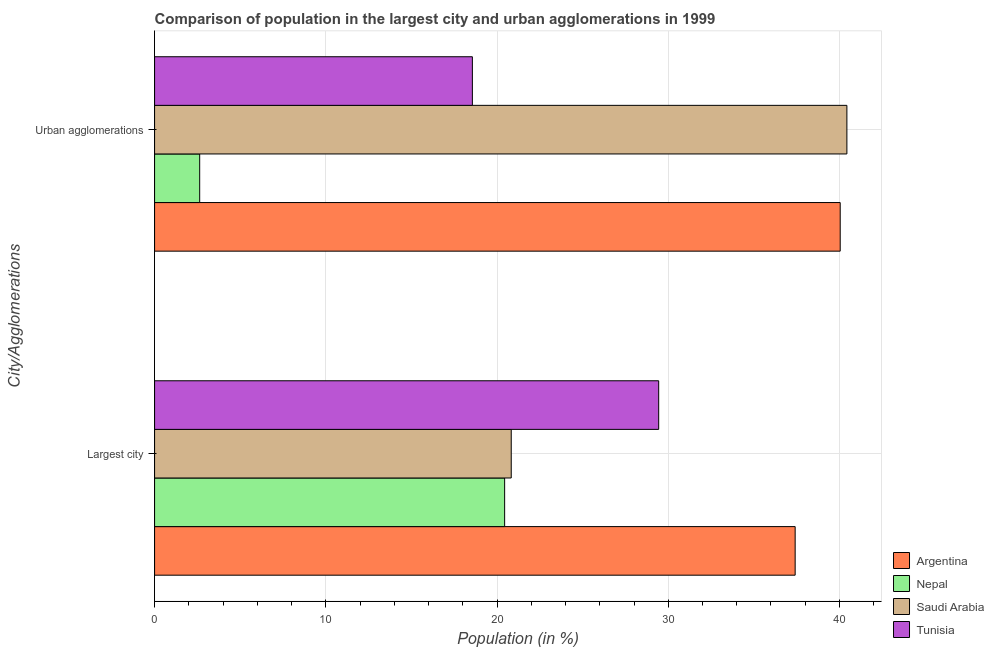How many different coloured bars are there?
Offer a terse response. 4. How many groups of bars are there?
Give a very brief answer. 2. Are the number of bars on each tick of the Y-axis equal?
Your answer should be compact. Yes. How many bars are there on the 1st tick from the top?
Your answer should be very brief. 4. How many bars are there on the 1st tick from the bottom?
Your answer should be compact. 4. What is the label of the 2nd group of bars from the top?
Your response must be concise. Largest city. What is the population in urban agglomerations in Tunisia?
Give a very brief answer. 18.56. Across all countries, what is the maximum population in the largest city?
Make the answer very short. 37.41. Across all countries, what is the minimum population in the largest city?
Offer a terse response. 20.45. In which country was the population in urban agglomerations maximum?
Give a very brief answer. Saudi Arabia. In which country was the population in the largest city minimum?
Your answer should be compact. Nepal. What is the total population in the largest city in the graph?
Make the answer very short. 108.13. What is the difference between the population in urban agglomerations in Argentina and that in Nepal?
Your answer should be compact. 37.41. What is the difference between the population in urban agglomerations in Saudi Arabia and the population in the largest city in Argentina?
Your response must be concise. 3.02. What is the average population in the largest city per country?
Keep it short and to the point. 27.03. What is the difference between the population in the largest city and population in urban agglomerations in Tunisia?
Your answer should be very brief. 10.88. What is the ratio of the population in urban agglomerations in Saudi Arabia to that in Argentina?
Provide a succinct answer. 1.01. Is the population in urban agglomerations in Tunisia less than that in Nepal?
Provide a succinct answer. No. In how many countries, is the population in the largest city greater than the average population in the largest city taken over all countries?
Ensure brevity in your answer.  2. What does the 1st bar from the top in Largest city represents?
Make the answer very short. Tunisia. What does the 1st bar from the bottom in Urban agglomerations represents?
Make the answer very short. Argentina. How many countries are there in the graph?
Offer a terse response. 4. What is the difference between two consecutive major ticks on the X-axis?
Your answer should be very brief. 10. Where does the legend appear in the graph?
Offer a very short reply. Bottom right. What is the title of the graph?
Make the answer very short. Comparison of population in the largest city and urban agglomerations in 1999. Does "Europe(developing only)" appear as one of the legend labels in the graph?
Give a very brief answer. No. What is the label or title of the Y-axis?
Keep it short and to the point. City/Agglomerations. What is the Population (in %) of Argentina in Largest city?
Give a very brief answer. 37.41. What is the Population (in %) of Nepal in Largest city?
Offer a terse response. 20.45. What is the Population (in %) in Saudi Arabia in Largest city?
Offer a very short reply. 20.83. What is the Population (in %) of Tunisia in Largest city?
Ensure brevity in your answer.  29.44. What is the Population (in %) of Argentina in Urban agglomerations?
Ensure brevity in your answer.  40.04. What is the Population (in %) in Nepal in Urban agglomerations?
Provide a succinct answer. 2.63. What is the Population (in %) in Saudi Arabia in Urban agglomerations?
Provide a succinct answer. 40.43. What is the Population (in %) in Tunisia in Urban agglomerations?
Your response must be concise. 18.56. Across all City/Agglomerations, what is the maximum Population (in %) of Argentina?
Give a very brief answer. 40.04. Across all City/Agglomerations, what is the maximum Population (in %) in Nepal?
Ensure brevity in your answer.  20.45. Across all City/Agglomerations, what is the maximum Population (in %) in Saudi Arabia?
Your answer should be compact. 40.43. Across all City/Agglomerations, what is the maximum Population (in %) in Tunisia?
Provide a short and direct response. 29.44. Across all City/Agglomerations, what is the minimum Population (in %) in Argentina?
Ensure brevity in your answer.  37.41. Across all City/Agglomerations, what is the minimum Population (in %) of Nepal?
Ensure brevity in your answer.  2.63. Across all City/Agglomerations, what is the minimum Population (in %) in Saudi Arabia?
Your answer should be compact. 20.83. Across all City/Agglomerations, what is the minimum Population (in %) of Tunisia?
Keep it short and to the point. 18.56. What is the total Population (in %) in Argentina in the graph?
Offer a very short reply. 77.45. What is the total Population (in %) in Nepal in the graph?
Give a very brief answer. 23.08. What is the total Population (in %) of Saudi Arabia in the graph?
Offer a very short reply. 61.26. What is the total Population (in %) in Tunisia in the graph?
Give a very brief answer. 48. What is the difference between the Population (in %) of Argentina in Largest city and that in Urban agglomerations?
Make the answer very short. -2.63. What is the difference between the Population (in %) in Nepal in Largest city and that in Urban agglomerations?
Offer a terse response. 17.81. What is the difference between the Population (in %) in Saudi Arabia in Largest city and that in Urban agglomerations?
Offer a very short reply. -19.6. What is the difference between the Population (in %) in Tunisia in Largest city and that in Urban agglomerations?
Make the answer very short. 10.88. What is the difference between the Population (in %) of Argentina in Largest city and the Population (in %) of Nepal in Urban agglomerations?
Give a very brief answer. 34.78. What is the difference between the Population (in %) of Argentina in Largest city and the Population (in %) of Saudi Arabia in Urban agglomerations?
Your response must be concise. -3.02. What is the difference between the Population (in %) in Argentina in Largest city and the Population (in %) in Tunisia in Urban agglomerations?
Make the answer very short. 18.85. What is the difference between the Population (in %) of Nepal in Largest city and the Population (in %) of Saudi Arabia in Urban agglomerations?
Your response must be concise. -19.99. What is the difference between the Population (in %) in Nepal in Largest city and the Population (in %) in Tunisia in Urban agglomerations?
Offer a terse response. 1.88. What is the difference between the Population (in %) of Saudi Arabia in Largest city and the Population (in %) of Tunisia in Urban agglomerations?
Make the answer very short. 2.27. What is the average Population (in %) of Argentina per City/Agglomerations?
Ensure brevity in your answer.  38.73. What is the average Population (in %) in Nepal per City/Agglomerations?
Ensure brevity in your answer.  11.54. What is the average Population (in %) of Saudi Arabia per City/Agglomerations?
Keep it short and to the point. 30.63. What is the average Population (in %) in Tunisia per City/Agglomerations?
Keep it short and to the point. 24. What is the difference between the Population (in %) in Argentina and Population (in %) in Nepal in Largest city?
Provide a short and direct response. 16.97. What is the difference between the Population (in %) of Argentina and Population (in %) of Saudi Arabia in Largest city?
Your answer should be very brief. 16.58. What is the difference between the Population (in %) in Argentina and Population (in %) in Tunisia in Largest city?
Keep it short and to the point. 7.97. What is the difference between the Population (in %) of Nepal and Population (in %) of Saudi Arabia in Largest city?
Ensure brevity in your answer.  -0.39. What is the difference between the Population (in %) of Nepal and Population (in %) of Tunisia in Largest city?
Provide a succinct answer. -9. What is the difference between the Population (in %) of Saudi Arabia and Population (in %) of Tunisia in Largest city?
Keep it short and to the point. -8.61. What is the difference between the Population (in %) of Argentina and Population (in %) of Nepal in Urban agglomerations?
Make the answer very short. 37.41. What is the difference between the Population (in %) in Argentina and Population (in %) in Saudi Arabia in Urban agglomerations?
Offer a terse response. -0.39. What is the difference between the Population (in %) of Argentina and Population (in %) of Tunisia in Urban agglomerations?
Your response must be concise. 21.48. What is the difference between the Population (in %) in Nepal and Population (in %) in Saudi Arabia in Urban agglomerations?
Your answer should be very brief. -37.8. What is the difference between the Population (in %) of Nepal and Population (in %) of Tunisia in Urban agglomerations?
Provide a succinct answer. -15.93. What is the difference between the Population (in %) of Saudi Arabia and Population (in %) of Tunisia in Urban agglomerations?
Keep it short and to the point. 21.87. What is the ratio of the Population (in %) in Argentina in Largest city to that in Urban agglomerations?
Ensure brevity in your answer.  0.93. What is the ratio of the Population (in %) of Nepal in Largest city to that in Urban agglomerations?
Provide a short and direct response. 7.76. What is the ratio of the Population (in %) in Saudi Arabia in Largest city to that in Urban agglomerations?
Your response must be concise. 0.52. What is the ratio of the Population (in %) of Tunisia in Largest city to that in Urban agglomerations?
Offer a terse response. 1.59. What is the difference between the highest and the second highest Population (in %) in Argentina?
Your answer should be compact. 2.63. What is the difference between the highest and the second highest Population (in %) in Nepal?
Your answer should be very brief. 17.81. What is the difference between the highest and the second highest Population (in %) in Saudi Arabia?
Ensure brevity in your answer.  19.6. What is the difference between the highest and the second highest Population (in %) in Tunisia?
Provide a short and direct response. 10.88. What is the difference between the highest and the lowest Population (in %) in Argentina?
Keep it short and to the point. 2.63. What is the difference between the highest and the lowest Population (in %) of Nepal?
Your answer should be very brief. 17.81. What is the difference between the highest and the lowest Population (in %) of Saudi Arabia?
Provide a short and direct response. 19.6. What is the difference between the highest and the lowest Population (in %) of Tunisia?
Ensure brevity in your answer.  10.88. 